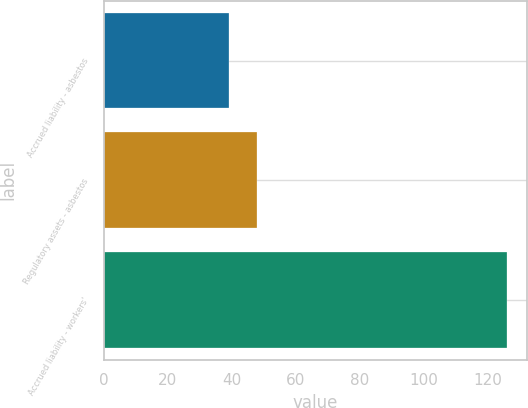Convert chart to OTSL. <chart><loc_0><loc_0><loc_500><loc_500><bar_chart><fcel>Accrued liability - asbestos<fcel>Regulatory assets - asbestos<fcel>Accrued liability - workers'<nl><fcel>39<fcel>47.7<fcel>126<nl></chart> 